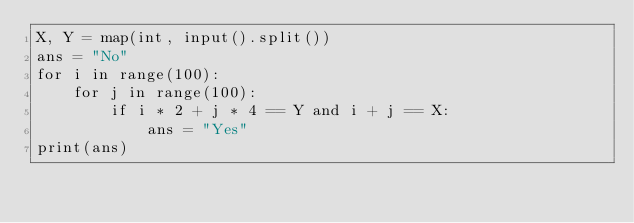Convert code to text. <code><loc_0><loc_0><loc_500><loc_500><_Python_>X, Y = map(int, input().split())
ans = "No"
for i in range(100):
    for j in range(100):
        if i * 2 + j * 4 == Y and i + j == X:
            ans = "Yes"
print(ans)
</code> 